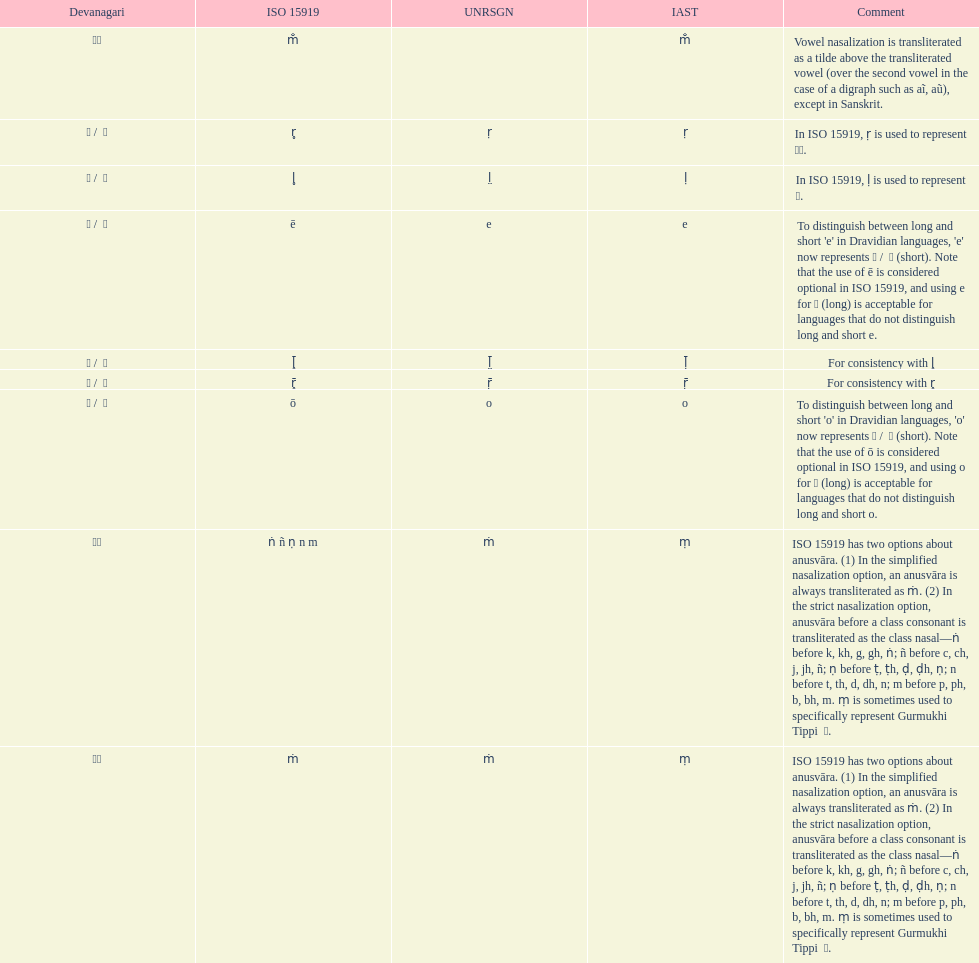Which devanagari transliteration is displayed at the beginning of the table? ए / े. 